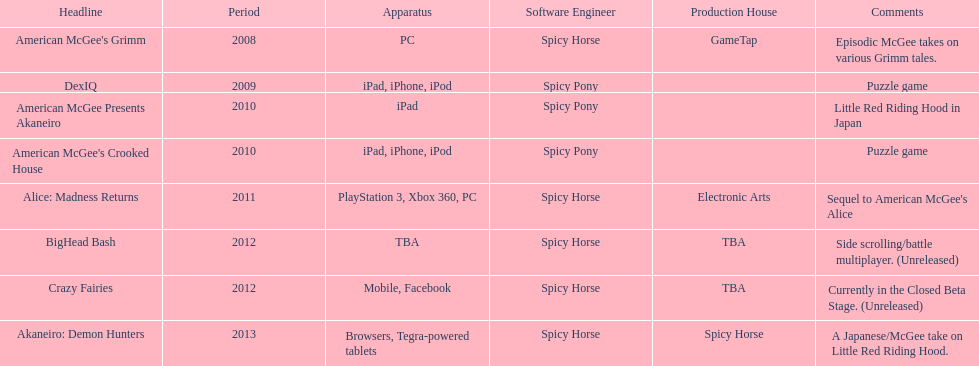What was the last game created by spicy horse Akaneiro: Demon Hunters. 